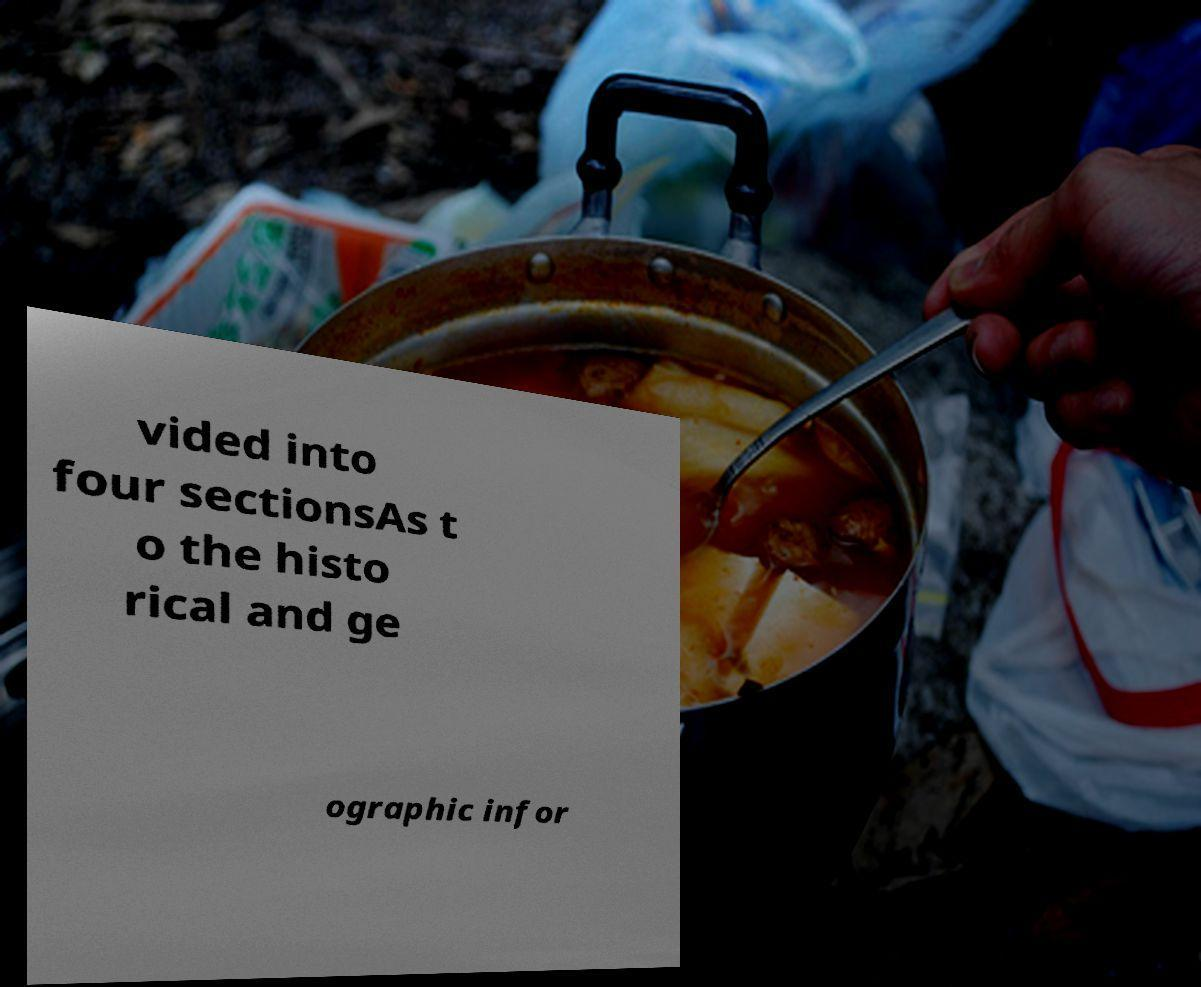There's text embedded in this image that I need extracted. Can you transcribe it verbatim? vided into four sectionsAs t o the histo rical and ge ographic infor 